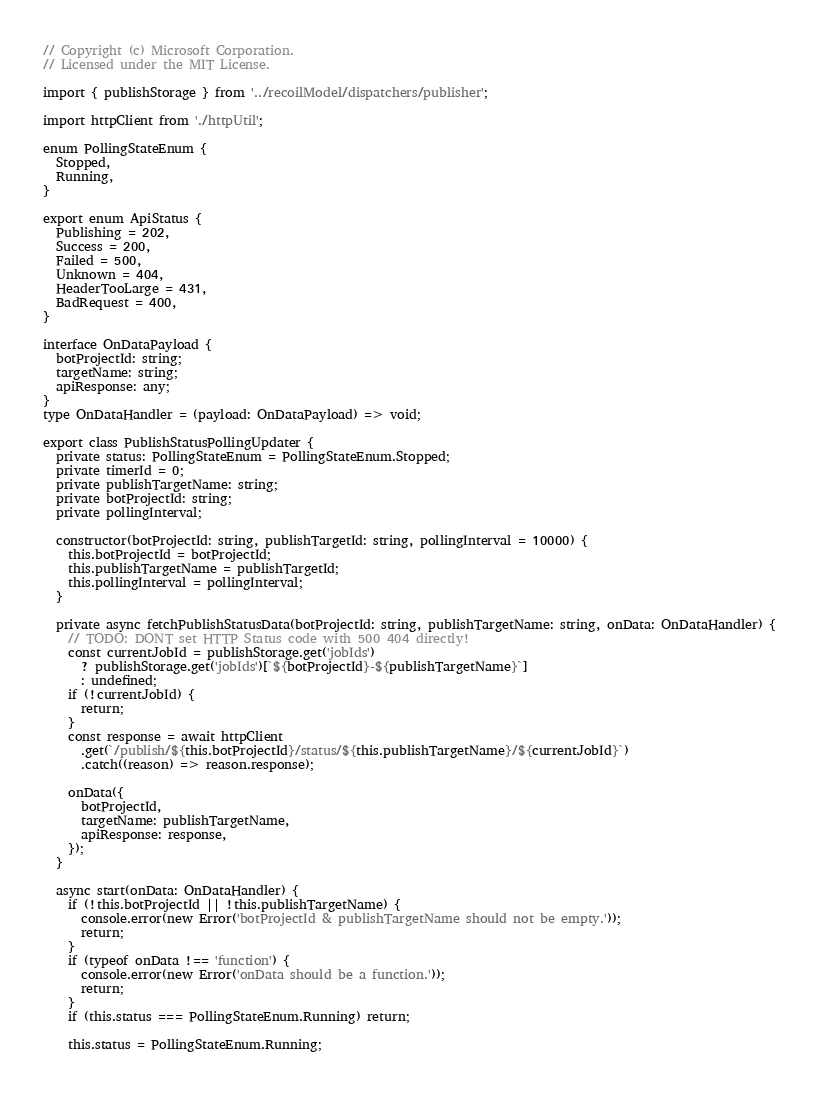Convert code to text. <code><loc_0><loc_0><loc_500><loc_500><_TypeScript_>// Copyright (c) Microsoft Corporation.
// Licensed under the MIT License.

import { publishStorage } from '../recoilModel/dispatchers/publisher';

import httpClient from './httpUtil';

enum PollingStateEnum {
  Stopped,
  Running,
}

export enum ApiStatus {
  Publishing = 202,
  Success = 200,
  Failed = 500,
  Unknown = 404,
  HeaderTooLarge = 431,
  BadRequest = 400,
}

interface OnDataPayload {
  botProjectId: string;
  targetName: string;
  apiResponse: any;
}
type OnDataHandler = (payload: OnDataPayload) => void;

export class PublishStatusPollingUpdater {
  private status: PollingStateEnum = PollingStateEnum.Stopped;
  private timerId = 0;
  private publishTargetName: string;
  private botProjectId: string;
  private pollingInterval;

  constructor(botProjectId: string, publishTargetId: string, pollingInterval = 10000) {
    this.botProjectId = botProjectId;
    this.publishTargetName = publishTargetId;
    this.pollingInterval = pollingInterval;
  }

  private async fetchPublishStatusData(botProjectId: string, publishTargetName: string, onData: OnDataHandler) {
    // TODO: DONT set HTTP Status code with 500 404 directly!
    const currentJobId = publishStorage.get('jobIds')
      ? publishStorage.get('jobIds')[`${botProjectId}-${publishTargetName}`]
      : undefined;
    if (!currentJobId) {
      return;
    }
    const response = await httpClient
      .get(`/publish/${this.botProjectId}/status/${this.publishTargetName}/${currentJobId}`)
      .catch((reason) => reason.response);

    onData({
      botProjectId,
      targetName: publishTargetName,
      apiResponse: response,
    });
  }

  async start(onData: OnDataHandler) {
    if (!this.botProjectId || !this.publishTargetName) {
      console.error(new Error('botProjectId & publishTargetName should not be empty.'));
      return;
    }
    if (typeof onData !== 'function') {
      console.error(new Error('onData should be a function.'));
      return;
    }
    if (this.status === PollingStateEnum.Running) return;

    this.status = PollingStateEnum.Running;
</code> 